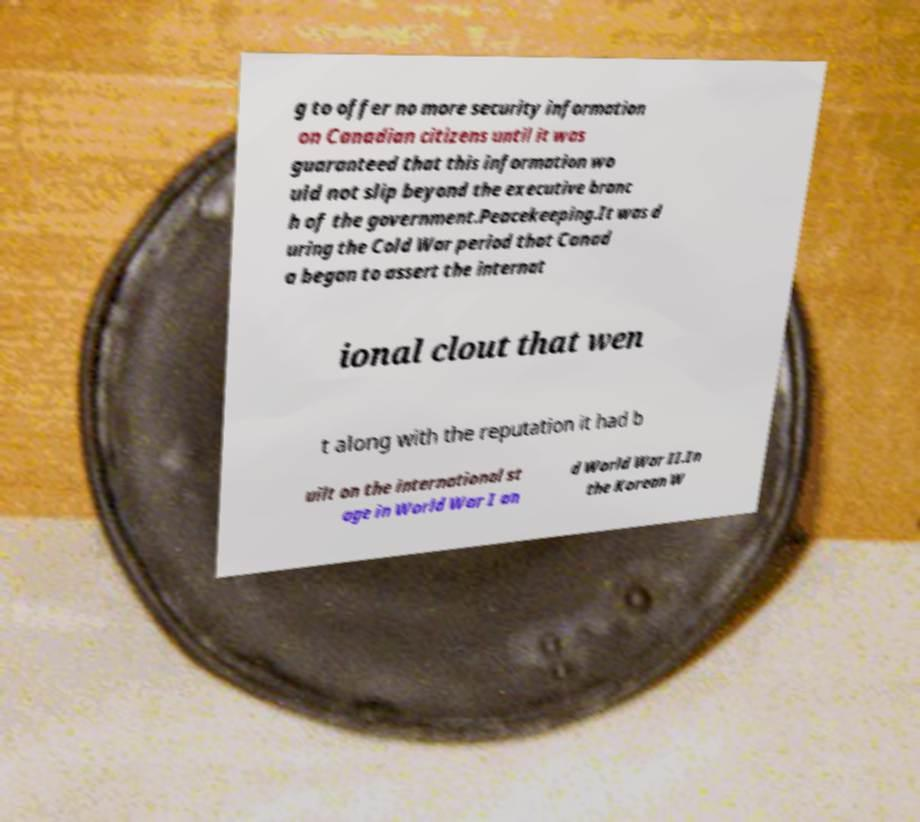There's text embedded in this image that I need extracted. Can you transcribe it verbatim? g to offer no more security information on Canadian citizens until it was guaranteed that this information wo uld not slip beyond the executive branc h of the government.Peacekeeping.It was d uring the Cold War period that Canad a began to assert the internat ional clout that wen t along with the reputation it had b uilt on the international st age in World War I an d World War II.In the Korean W 